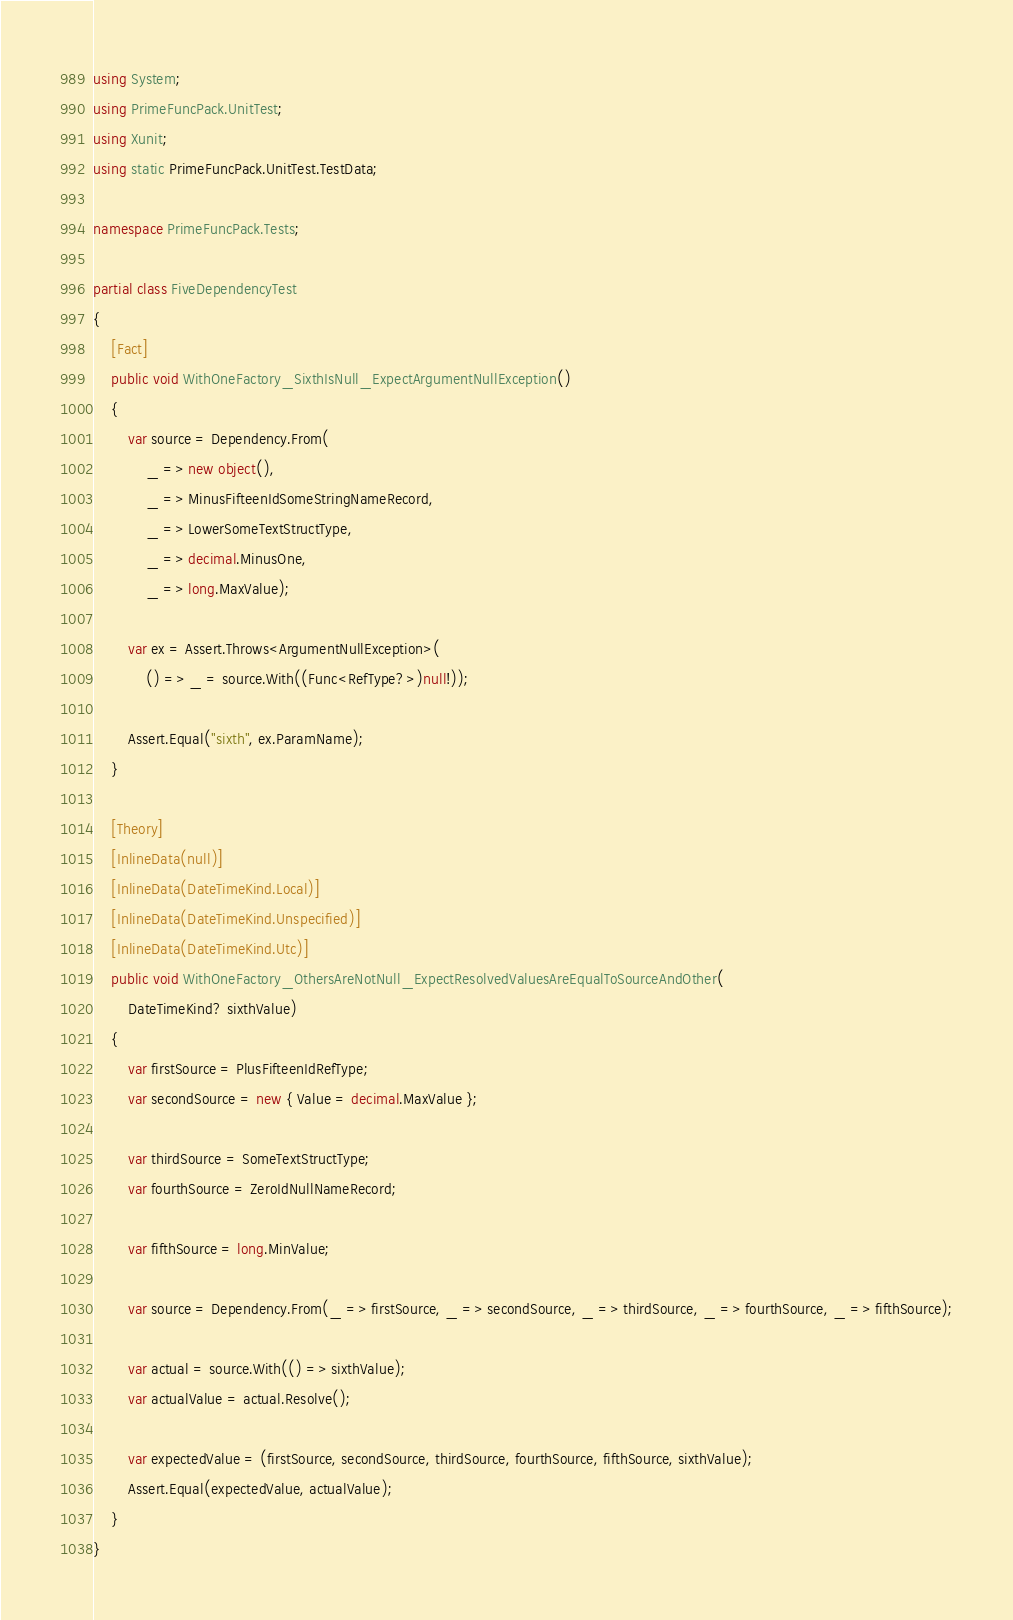<code> <loc_0><loc_0><loc_500><loc_500><_C#_>using System;
using PrimeFuncPack.UnitTest;
using Xunit;
using static PrimeFuncPack.UnitTest.TestData;

namespace PrimeFuncPack.Tests;

partial class FiveDependencyTest
{
    [Fact]
    public void WithOneFactory_SixthIsNull_ExpectArgumentNullException()
    {
        var source = Dependency.From(
            _ => new object(),
            _ => MinusFifteenIdSomeStringNameRecord,
            _ => LowerSomeTextStructType,
            _ => decimal.MinusOne,
            _ => long.MaxValue);

        var ex = Assert.Throws<ArgumentNullException>(
            () => _ = source.With((Func<RefType?>)null!));

        Assert.Equal("sixth", ex.ParamName);
    }

    [Theory]
    [InlineData(null)]
    [InlineData(DateTimeKind.Local)]
    [InlineData(DateTimeKind.Unspecified)]
    [InlineData(DateTimeKind.Utc)]
    public void WithOneFactory_OthersAreNotNull_ExpectResolvedValuesAreEqualToSourceAndOther(
        DateTimeKind? sixthValue)
    {
        var firstSource = PlusFifteenIdRefType;
        var secondSource = new { Value = decimal.MaxValue };

        var thirdSource = SomeTextStructType;
        var fourthSource = ZeroIdNullNameRecord;

        var fifthSource = long.MinValue;

        var source = Dependency.From(_ => firstSource, _ => secondSource, _ => thirdSource, _ => fourthSource, _ => fifthSource);

        var actual = source.With(() => sixthValue);
        var actualValue = actual.Resolve();

        var expectedValue = (firstSource, secondSource, thirdSource, fourthSource, fifthSource, sixthValue);
        Assert.Equal(expectedValue, actualValue);
    }
}
</code> 